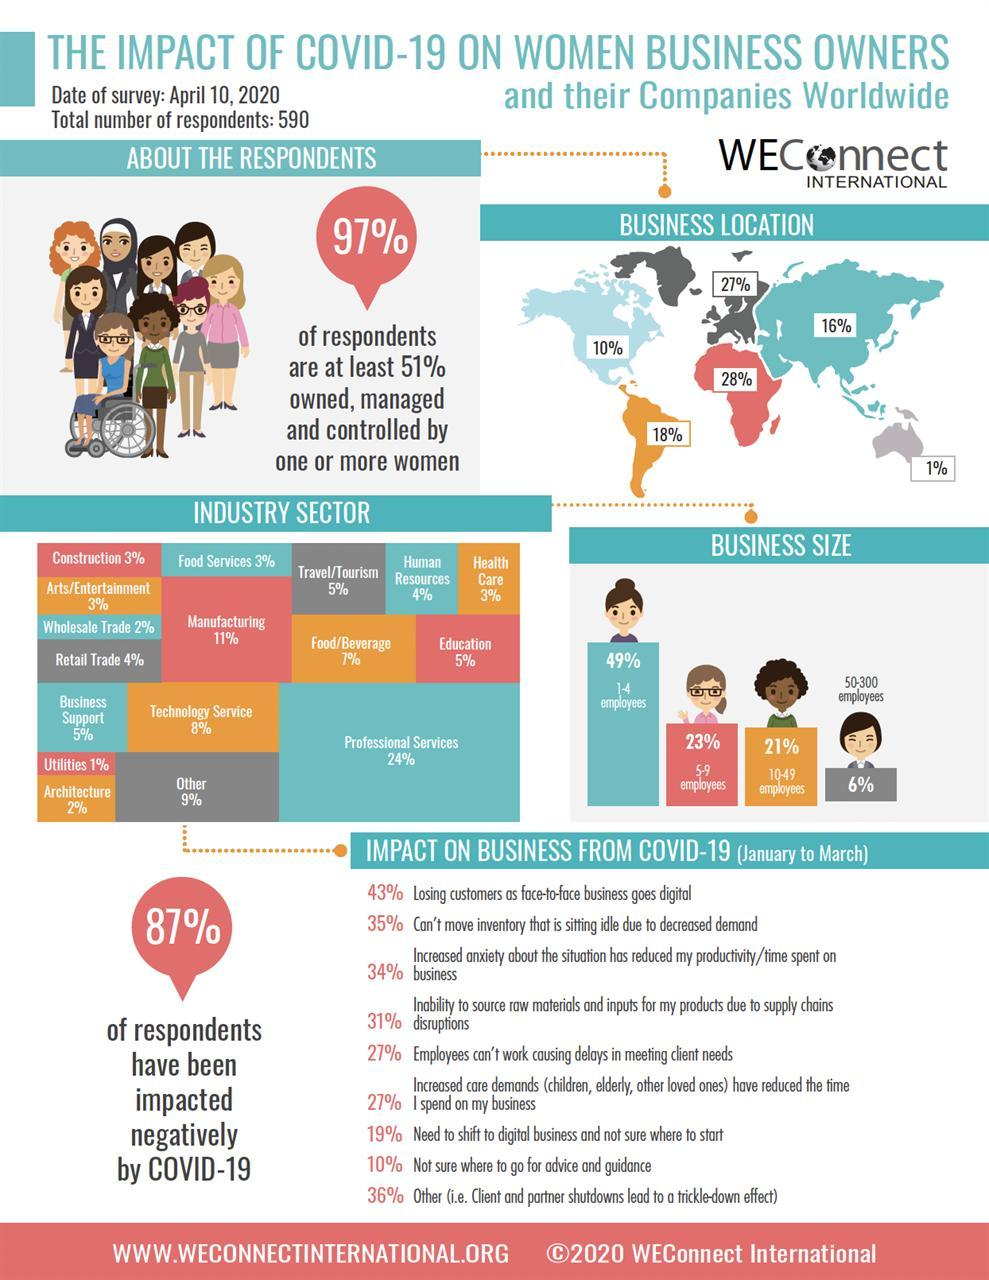What percent of businesses have 1-4 employees?
Answer the question with a short phrase. 49% By how much more, is the percentage of respondents in manufacturing sector higher than education sector? 6% What percent of respondents are in health care industry? 3% What percent of respondents are engaged in retail trade? 4% What percentage of respondents have businesses located in the red region on the map? 28% What percent of women business owners have been impacted negatively by covid-19? 87% What percent of of women owned businesses have more than 50 employees? 6% What percent of the respondents are engaged in trade, both wholesale and retail? 6% What percent of the respondents are engaged in wholesale trade? 2% What percent of respondents suffer customer loss due to digitalization? 43% How many employees are there in 'majority' of the women owned businesses? 1-4 employees What percent of the respondents are at least 51% owned or managed by other women? 97% What percent of businesses have 5-9 employees? 23% What percent of women owned businesses have 10-49 employees? 21% What percent of the respondents belong to education sector? 5% What percent of respondents intend to go digital but don't know how to? 19% Which industry are most of the respondents engaged in? Professional services 